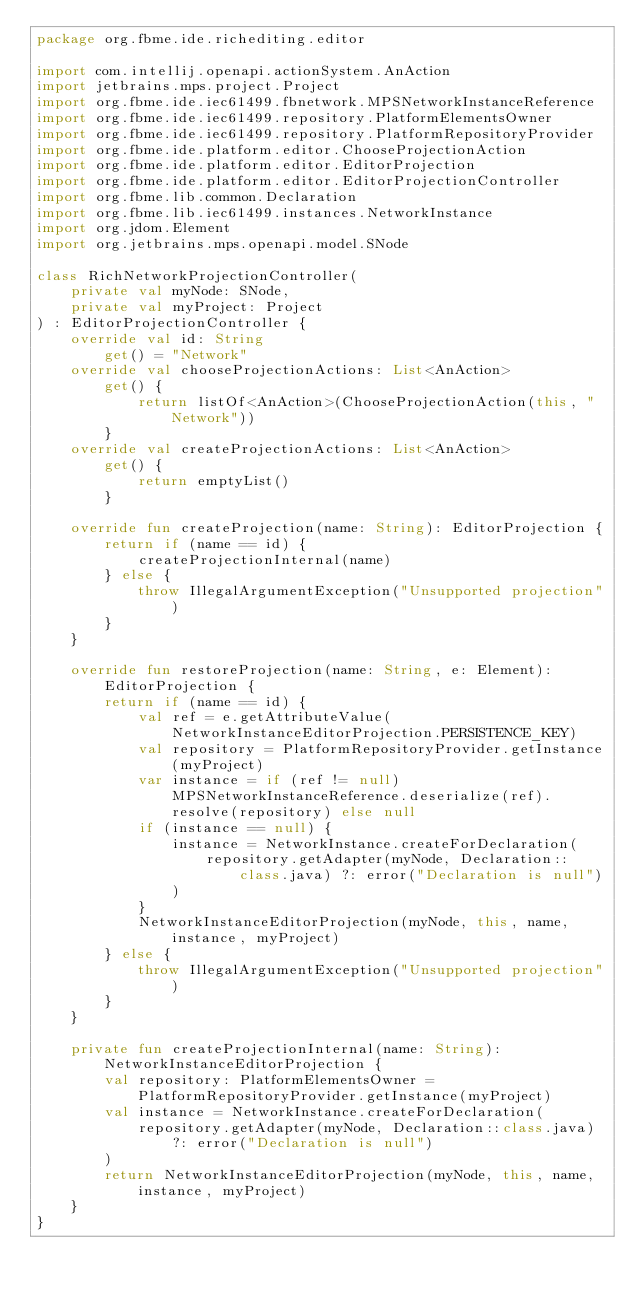<code> <loc_0><loc_0><loc_500><loc_500><_Kotlin_>package org.fbme.ide.richediting.editor

import com.intellij.openapi.actionSystem.AnAction
import jetbrains.mps.project.Project
import org.fbme.ide.iec61499.fbnetwork.MPSNetworkInstanceReference
import org.fbme.ide.iec61499.repository.PlatformElementsOwner
import org.fbme.ide.iec61499.repository.PlatformRepositoryProvider
import org.fbme.ide.platform.editor.ChooseProjectionAction
import org.fbme.ide.platform.editor.EditorProjection
import org.fbme.ide.platform.editor.EditorProjectionController
import org.fbme.lib.common.Declaration
import org.fbme.lib.iec61499.instances.NetworkInstance
import org.jdom.Element
import org.jetbrains.mps.openapi.model.SNode

class RichNetworkProjectionController(
    private val myNode: SNode,
    private val myProject: Project
) : EditorProjectionController {
    override val id: String
        get() = "Network"
    override val chooseProjectionActions: List<AnAction>
        get() {
            return listOf<AnAction>(ChooseProjectionAction(this, "Network"))
        }
    override val createProjectionActions: List<AnAction>
        get() {
            return emptyList()
        }

    override fun createProjection(name: String): EditorProjection {
        return if (name == id) {
            createProjectionInternal(name)
        } else {
            throw IllegalArgumentException("Unsupported projection")
        }
    }

    override fun restoreProjection(name: String, e: Element): EditorProjection {
        return if (name == id) {
            val ref = e.getAttributeValue(NetworkInstanceEditorProjection.PERSISTENCE_KEY)
            val repository = PlatformRepositoryProvider.getInstance(myProject)
            var instance = if (ref != null) MPSNetworkInstanceReference.deserialize(ref).resolve(repository) else null
            if (instance == null) {
                instance = NetworkInstance.createForDeclaration(
                    repository.getAdapter(myNode, Declaration::class.java) ?: error("Declaration is null")
                )
            }
            NetworkInstanceEditorProjection(myNode, this, name, instance, myProject)
        } else {
            throw IllegalArgumentException("Unsupported projection")
        }
    }

    private fun createProjectionInternal(name: String): NetworkInstanceEditorProjection {
        val repository: PlatformElementsOwner = PlatformRepositoryProvider.getInstance(myProject)
        val instance = NetworkInstance.createForDeclaration(
            repository.getAdapter(myNode, Declaration::class.java) ?: error("Declaration is null")
        )
        return NetworkInstanceEditorProjection(myNode, this, name, instance, myProject)
    }
}</code> 